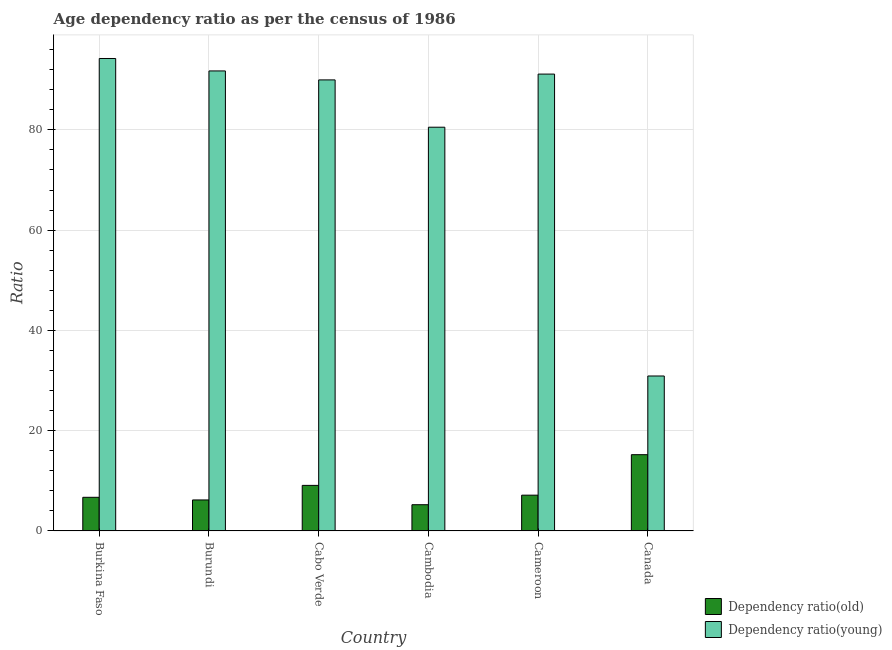How many bars are there on the 5th tick from the right?
Make the answer very short. 2. What is the label of the 2nd group of bars from the left?
Make the answer very short. Burundi. What is the age dependency ratio(young) in Cabo Verde?
Ensure brevity in your answer.  89.97. Across all countries, what is the maximum age dependency ratio(young)?
Give a very brief answer. 94.24. Across all countries, what is the minimum age dependency ratio(old)?
Offer a very short reply. 5.23. In which country was the age dependency ratio(old) maximum?
Make the answer very short. Canada. In which country was the age dependency ratio(old) minimum?
Your response must be concise. Cambodia. What is the total age dependency ratio(young) in the graph?
Your response must be concise. 478.56. What is the difference between the age dependency ratio(old) in Cambodia and that in Canada?
Provide a succinct answer. -9.98. What is the difference between the age dependency ratio(old) in Canada and the age dependency ratio(young) in Burundi?
Provide a short and direct response. -76.55. What is the average age dependency ratio(young) per country?
Your response must be concise. 79.76. What is the difference between the age dependency ratio(young) and age dependency ratio(old) in Cambodia?
Provide a short and direct response. 75.3. What is the ratio of the age dependency ratio(old) in Burkina Faso to that in Canada?
Your answer should be very brief. 0.44. Is the age dependency ratio(old) in Burkina Faso less than that in Cabo Verde?
Offer a terse response. Yes. What is the difference between the highest and the second highest age dependency ratio(young)?
Provide a short and direct response. 2.48. What is the difference between the highest and the lowest age dependency ratio(old)?
Provide a succinct answer. 9.98. What does the 2nd bar from the left in Burkina Faso represents?
Provide a succinct answer. Dependency ratio(young). What does the 1st bar from the right in Cambodia represents?
Provide a succinct answer. Dependency ratio(young). Are all the bars in the graph horizontal?
Keep it short and to the point. No. Does the graph contain any zero values?
Your response must be concise. No. Where does the legend appear in the graph?
Offer a very short reply. Bottom right. How many legend labels are there?
Ensure brevity in your answer.  2. How are the legend labels stacked?
Offer a very short reply. Vertical. What is the title of the graph?
Your answer should be compact. Age dependency ratio as per the census of 1986. Does "Male labor force" appear as one of the legend labels in the graph?
Your answer should be very brief. No. What is the label or title of the Y-axis?
Offer a very short reply. Ratio. What is the Ratio in Dependency ratio(old) in Burkina Faso?
Your response must be concise. 6.71. What is the Ratio in Dependency ratio(young) in Burkina Faso?
Your answer should be compact. 94.24. What is the Ratio in Dependency ratio(old) in Burundi?
Provide a succinct answer. 6.18. What is the Ratio of Dependency ratio(young) in Burundi?
Offer a terse response. 91.76. What is the Ratio of Dependency ratio(old) in Cabo Verde?
Your answer should be very brief. 9.09. What is the Ratio of Dependency ratio(young) in Cabo Verde?
Give a very brief answer. 89.97. What is the Ratio of Dependency ratio(old) in Cambodia?
Make the answer very short. 5.23. What is the Ratio in Dependency ratio(young) in Cambodia?
Provide a succinct answer. 80.54. What is the Ratio in Dependency ratio(old) in Cameroon?
Provide a succinct answer. 7.14. What is the Ratio in Dependency ratio(young) in Cameroon?
Make the answer very short. 91.13. What is the Ratio in Dependency ratio(old) in Canada?
Your answer should be very brief. 15.21. What is the Ratio of Dependency ratio(young) in Canada?
Keep it short and to the point. 30.91. Across all countries, what is the maximum Ratio in Dependency ratio(old)?
Ensure brevity in your answer.  15.21. Across all countries, what is the maximum Ratio in Dependency ratio(young)?
Your answer should be compact. 94.24. Across all countries, what is the minimum Ratio of Dependency ratio(old)?
Your answer should be compact. 5.23. Across all countries, what is the minimum Ratio in Dependency ratio(young)?
Provide a short and direct response. 30.91. What is the total Ratio of Dependency ratio(old) in the graph?
Keep it short and to the point. 49.56. What is the total Ratio of Dependency ratio(young) in the graph?
Provide a short and direct response. 478.56. What is the difference between the Ratio in Dependency ratio(old) in Burkina Faso and that in Burundi?
Make the answer very short. 0.53. What is the difference between the Ratio in Dependency ratio(young) in Burkina Faso and that in Burundi?
Your answer should be very brief. 2.48. What is the difference between the Ratio of Dependency ratio(old) in Burkina Faso and that in Cabo Verde?
Offer a terse response. -2.38. What is the difference between the Ratio in Dependency ratio(young) in Burkina Faso and that in Cabo Verde?
Keep it short and to the point. 4.27. What is the difference between the Ratio of Dependency ratio(old) in Burkina Faso and that in Cambodia?
Provide a succinct answer. 1.48. What is the difference between the Ratio of Dependency ratio(young) in Burkina Faso and that in Cambodia?
Keep it short and to the point. 13.71. What is the difference between the Ratio in Dependency ratio(old) in Burkina Faso and that in Cameroon?
Provide a short and direct response. -0.43. What is the difference between the Ratio in Dependency ratio(young) in Burkina Faso and that in Cameroon?
Offer a terse response. 3.11. What is the difference between the Ratio of Dependency ratio(old) in Burkina Faso and that in Canada?
Give a very brief answer. -8.5. What is the difference between the Ratio in Dependency ratio(young) in Burkina Faso and that in Canada?
Make the answer very short. 63.33. What is the difference between the Ratio in Dependency ratio(old) in Burundi and that in Cabo Verde?
Your response must be concise. -2.9. What is the difference between the Ratio of Dependency ratio(young) in Burundi and that in Cabo Verde?
Provide a succinct answer. 1.79. What is the difference between the Ratio of Dependency ratio(old) in Burundi and that in Cambodia?
Your answer should be compact. 0.95. What is the difference between the Ratio in Dependency ratio(young) in Burundi and that in Cambodia?
Make the answer very short. 11.22. What is the difference between the Ratio of Dependency ratio(old) in Burundi and that in Cameroon?
Offer a terse response. -0.95. What is the difference between the Ratio of Dependency ratio(young) in Burundi and that in Cameroon?
Your answer should be compact. 0.63. What is the difference between the Ratio in Dependency ratio(old) in Burundi and that in Canada?
Ensure brevity in your answer.  -9.03. What is the difference between the Ratio in Dependency ratio(young) in Burundi and that in Canada?
Give a very brief answer. 60.85. What is the difference between the Ratio of Dependency ratio(old) in Cabo Verde and that in Cambodia?
Ensure brevity in your answer.  3.85. What is the difference between the Ratio of Dependency ratio(young) in Cabo Verde and that in Cambodia?
Provide a succinct answer. 9.44. What is the difference between the Ratio of Dependency ratio(old) in Cabo Verde and that in Cameroon?
Your response must be concise. 1.95. What is the difference between the Ratio in Dependency ratio(young) in Cabo Verde and that in Cameroon?
Make the answer very short. -1.16. What is the difference between the Ratio in Dependency ratio(old) in Cabo Verde and that in Canada?
Offer a very short reply. -6.12. What is the difference between the Ratio of Dependency ratio(young) in Cabo Verde and that in Canada?
Give a very brief answer. 59.06. What is the difference between the Ratio in Dependency ratio(old) in Cambodia and that in Cameroon?
Offer a very short reply. -1.9. What is the difference between the Ratio in Dependency ratio(young) in Cambodia and that in Cameroon?
Your response must be concise. -10.6. What is the difference between the Ratio in Dependency ratio(old) in Cambodia and that in Canada?
Keep it short and to the point. -9.98. What is the difference between the Ratio in Dependency ratio(young) in Cambodia and that in Canada?
Provide a short and direct response. 49.63. What is the difference between the Ratio in Dependency ratio(old) in Cameroon and that in Canada?
Your answer should be compact. -8.08. What is the difference between the Ratio of Dependency ratio(young) in Cameroon and that in Canada?
Keep it short and to the point. 60.22. What is the difference between the Ratio in Dependency ratio(old) in Burkina Faso and the Ratio in Dependency ratio(young) in Burundi?
Ensure brevity in your answer.  -85.05. What is the difference between the Ratio in Dependency ratio(old) in Burkina Faso and the Ratio in Dependency ratio(young) in Cabo Verde?
Keep it short and to the point. -83.26. What is the difference between the Ratio in Dependency ratio(old) in Burkina Faso and the Ratio in Dependency ratio(young) in Cambodia?
Keep it short and to the point. -73.83. What is the difference between the Ratio in Dependency ratio(old) in Burkina Faso and the Ratio in Dependency ratio(young) in Cameroon?
Make the answer very short. -84.42. What is the difference between the Ratio of Dependency ratio(old) in Burkina Faso and the Ratio of Dependency ratio(young) in Canada?
Your response must be concise. -24.2. What is the difference between the Ratio of Dependency ratio(old) in Burundi and the Ratio of Dependency ratio(young) in Cabo Verde?
Provide a short and direct response. -83.79. What is the difference between the Ratio in Dependency ratio(old) in Burundi and the Ratio in Dependency ratio(young) in Cambodia?
Provide a short and direct response. -74.35. What is the difference between the Ratio in Dependency ratio(old) in Burundi and the Ratio in Dependency ratio(young) in Cameroon?
Your answer should be compact. -84.95. What is the difference between the Ratio in Dependency ratio(old) in Burundi and the Ratio in Dependency ratio(young) in Canada?
Keep it short and to the point. -24.73. What is the difference between the Ratio in Dependency ratio(old) in Cabo Verde and the Ratio in Dependency ratio(young) in Cambodia?
Offer a very short reply. -71.45. What is the difference between the Ratio of Dependency ratio(old) in Cabo Verde and the Ratio of Dependency ratio(young) in Cameroon?
Keep it short and to the point. -82.05. What is the difference between the Ratio of Dependency ratio(old) in Cabo Verde and the Ratio of Dependency ratio(young) in Canada?
Ensure brevity in your answer.  -21.82. What is the difference between the Ratio in Dependency ratio(old) in Cambodia and the Ratio in Dependency ratio(young) in Cameroon?
Provide a short and direct response. -85.9. What is the difference between the Ratio in Dependency ratio(old) in Cambodia and the Ratio in Dependency ratio(young) in Canada?
Your answer should be compact. -25.68. What is the difference between the Ratio in Dependency ratio(old) in Cameroon and the Ratio in Dependency ratio(young) in Canada?
Your answer should be very brief. -23.77. What is the average Ratio in Dependency ratio(old) per country?
Provide a succinct answer. 8.26. What is the average Ratio of Dependency ratio(young) per country?
Provide a short and direct response. 79.76. What is the difference between the Ratio in Dependency ratio(old) and Ratio in Dependency ratio(young) in Burkina Faso?
Provide a succinct answer. -87.53. What is the difference between the Ratio of Dependency ratio(old) and Ratio of Dependency ratio(young) in Burundi?
Ensure brevity in your answer.  -85.58. What is the difference between the Ratio of Dependency ratio(old) and Ratio of Dependency ratio(young) in Cabo Verde?
Your answer should be very brief. -80.89. What is the difference between the Ratio in Dependency ratio(old) and Ratio in Dependency ratio(young) in Cambodia?
Your answer should be very brief. -75.3. What is the difference between the Ratio of Dependency ratio(old) and Ratio of Dependency ratio(young) in Cameroon?
Ensure brevity in your answer.  -84. What is the difference between the Ratio in Dependency ratio(old) and Ratio in Dependency ratio(young) in Canada?
Keep it short and to the point. -15.7. What is the ratio of the Ratio of Dependency ratio(old) in Burkina Faso to that in Burundi?
Your response must be concise. 1.09. What is the ratio of the Ratio in Dependency ratio(young) in Burkina Faso to that in Burundi?
Offer a very short reply. 1.03. What is the ratio of the Ratio in Dependency ratio(old) in Burkina Faso to that in Cabo Verde?
Keep it short and to the point. 0.74. What is the ratio of the Ratio in Dependency ratio(young) in Burkina Faso to that in Cabo Verde?
Make the answer very short. 1.05. What is the ratio of the Ratio in Dependency ratio(old) in Burkina Faso to that in Cambodia?
Offer a terse response. 1.28. What is the ratio of the Ratio in Dependency ratio(young) in Burkina Faso to that in Cambodia?
Your answer should be very brief. 1.17. What is the ratio of the Ratio in Dependency ratio(old) in Burkina Faso to that in Cameroon?
Give a very brief answer. 0.94. What is the ratio of the Ratio in Dependency ratio(young) in Burkina Faso to that in Cameroon?
Keep it short and to the point. 1.03. What is the ratio of the Ratio in Dependency ratio(old) in Burkina Faso to that in Canada?
Ensure brevity in your answer.  0.44. What is the ratio of the Ratio in Dependency ratio(young) in Burkina Faso to that in Canada?
Your response must be concise. 3.05. What is the ratio of the Ratio in Dependency ratio(old) in Burundi to that in Cabo Verde?
Your response must be concise. 0.68. What is the ratio of the Ratio of Dependency ratio(young) in Burundi to that in Cabo Verde?
Your answer should be very brief. 1.02. What is the ratio of the Ratio in Dependency ratio(old) in Burundi to that in Cambodia?
Provide a succinct answer. 1.18. What is the ratio of the Ratio of Dependency ratio(young) in Burundi to that in Cambodia?
Your answer should be very brief. 1.14. What is the ratio of the Ratio in Dependency ratio(old) in Burundi to that in Cameroon?
Offer a very short reply. 0.87. What is the ratio of the Ratio in Dependency ratio(old) in Burundi to that in Canada?
Provide a short and direct response. 0.41. What is the ratio of the Ratio of Dependency ratio(young) in Burundi to that in Canada?
Make the answer very short. 2.97. What is the ratio of the Ratio of Dependency ratio(old) in Cabo Verde to that in Cambodia?
Provide a succinct answer. 1.74. What is the ratio of the Ratio in Dependency ratio(young) in Cabo Verde to that in Cambodia?
Ensure brevity in your answer.  1.12. What is the ratio of the Ratio in Dependency ratio(old) in Cabo Verde to that in Cameroon?
Your answer should be compact. 1.27. What is the ratio of the Ratio of Dependency ratio(young) in Cabo Verde to that in Cameroon?
Your answer should be compact. 0.99. What is the ratio of the Ratio of Dependency ratio(old) in Cabo Verde to that in Canada?
Give a very brief answer. 0.6. What is the ratio of the Ratio in Dependency ratio(young) in Cabo Verde to that in Canada?
Ensure brevity in your answer.  2.91. What is the ratio of the Ratio in Dependency ratio(old) in Cambodia to that in Cameroon?
Your answer should be very brief. 0.73. What is the ratio of the Ratio of Dependency ratio(young) in Cambodia to that in Cameroon?
Provide a succinct answer. 0.88. What is the ratio of the Ratio in Dependency ratio(old) in Cambodia to that in Canada?
Your response must be concise. 0.34. What is the ratio of the Ratio of Dependency ratio(young) in Cambodia to that in Canada?
Offer a very short reply. 2.61. What is the ratio of the Ratio of Dependency ratio(old) in Cameroon to that in Canada?
Ensure brevity in your answer.  0.47. What is the ratio of the Ratio of Dependency ratio(young) in Cameroon to that in Canada?
Provide a succinct answer. 2.95. What is the difference between the highest and the second highest Ratio of Dependency ratio(old)?
Your response must be concise. 6.12. What is the difference between the highest and the second highest Ratio in Dependency ratio(young)?
Your answer should be very brief. 2.48. What is the difference between the highest and the lowest Ratio in Dependency ratio(old)?
Make the answer very short. 9.98. What is the difference between the highest and the lowest Ratio in Dependency ratio(young)?
Provide a short and direct response. 63.33. 